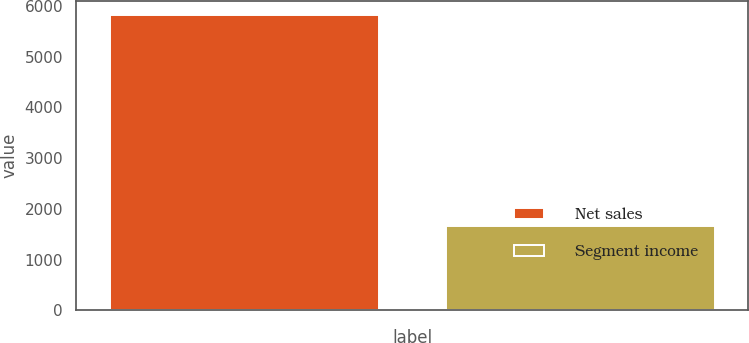Convert chart. <chart><loc_0><loc_0><loc_500><loc_500><bar_chart><fcel>Net sales<fcel>Segment income<nl><fcel>5812.7<fcel>1656.1<nl></chart> 